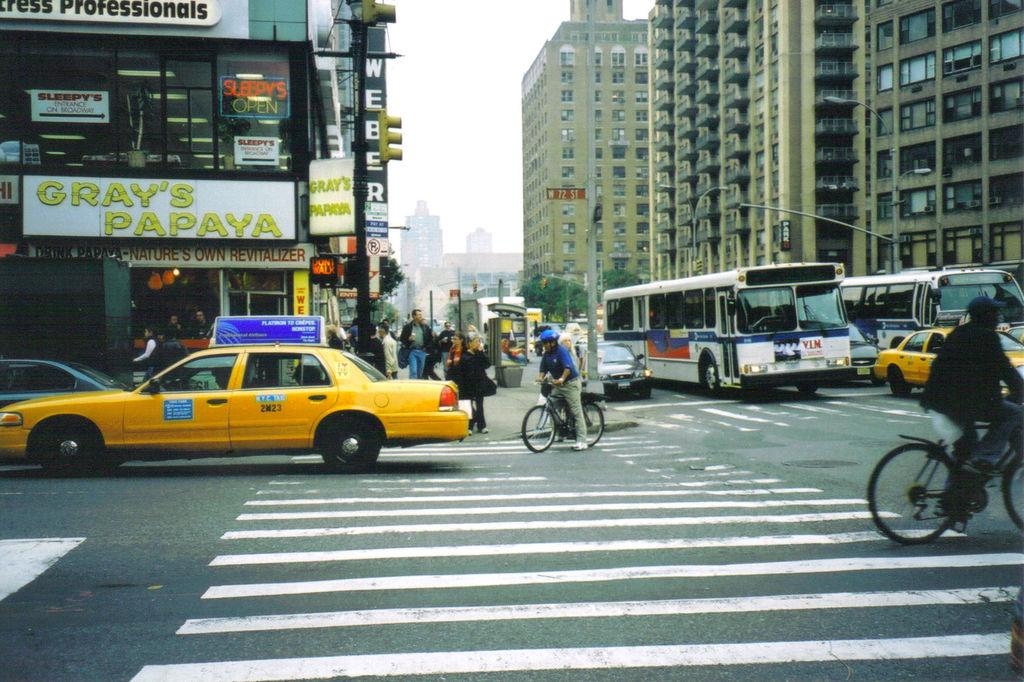<image>
Share a concise interpretation of the image provided. a sign on the street that says grays on it 